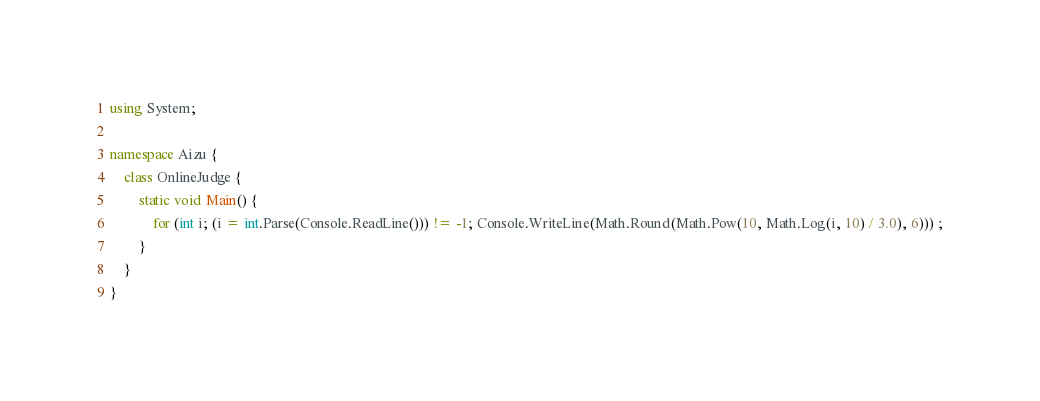Convert code to text. <code><loc_0><loc_0><loc_500><loc_500><_C#_>using System;

namespace Aizu {
    class OnlineJudge {
        static void Main() {
            for (int i; (i = int.Parse(Console.ReadLine())) != -1; Console.WriteLine(Math.Round(Math.Pow(10, Math.Log(i, 10) / 3.0), 6))) ;
        }
    }
}</code> 